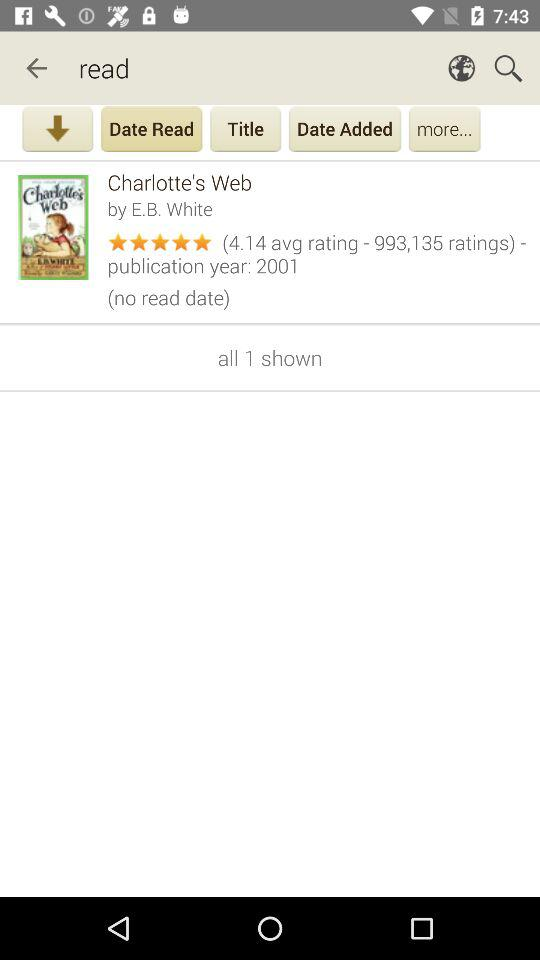What is the average rating of this book?
Answer the question using a single word or phrase. 4.14 